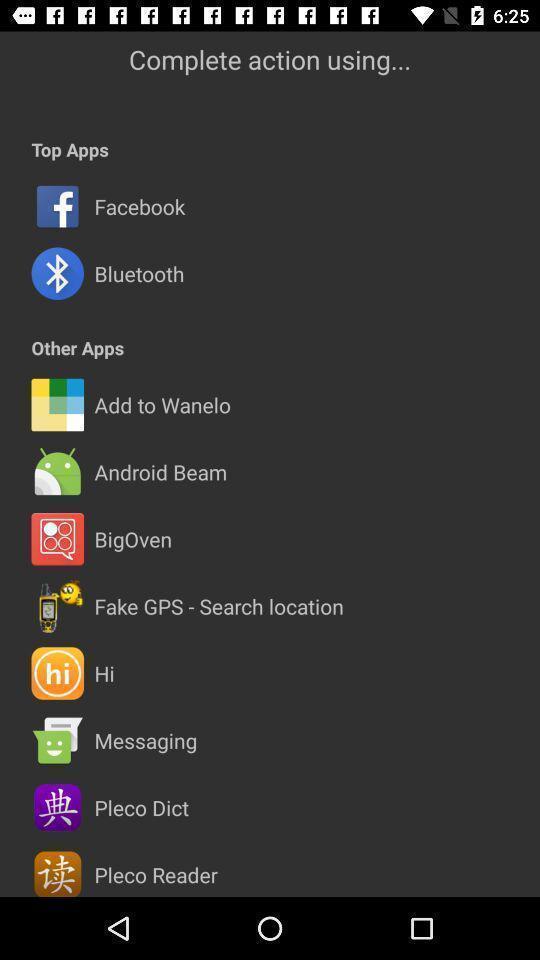What is the overall content of this screenshot? Screen of list of apps to complete action in app. 